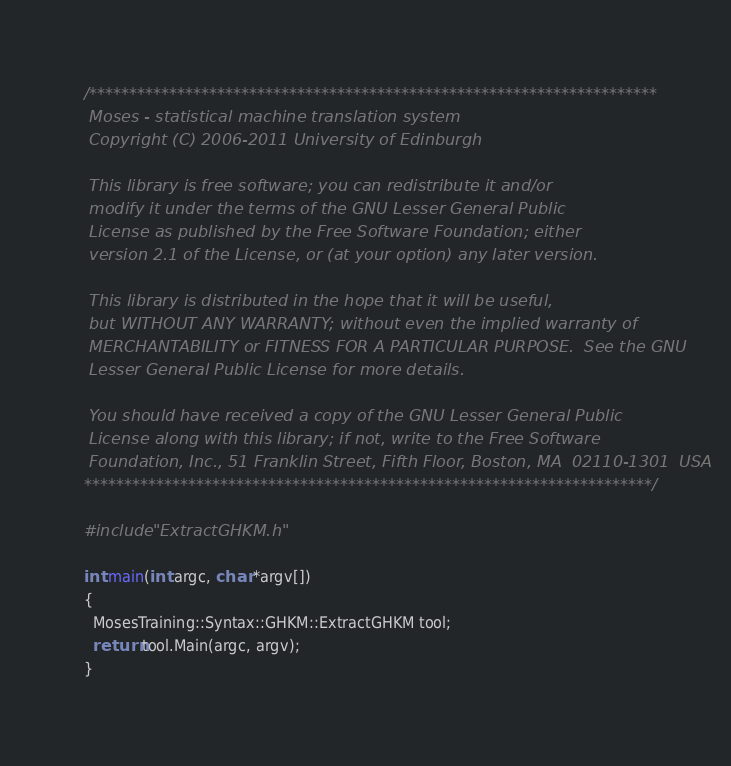Convert code to text. <code><loc_0><loc_0><loc_500><loc_500><_C++_>/***********************************************************************
 Moses - statistical machine translation system
 Copyright (C) 2006-2011 University of Edinburgh

 This library is free software; you can redistribute it and/or
 modify it under the terms of the GNU Lesser General Public
 License as published by the Free Software Foundation; either
 version 2.1 of the License, or (at your option) any later version.

 This library is distributed in the hope that it will be useful,
 but WITHOUT ANY WARRANTY; without even the implied warranty of
 MERCHANTABILITY or FITNESS FOR A PARTICULAR PURPOSE.  See the GNU
 Lesser General Public License for more details.

 You should have received a copy of the GNU Lesser General Public
 License along with this library; if not, write to the Free Software
 Foundation, Inc., 51 Franklin Street, Fifth Floor, Boston, MA  02110-1301  USA
***********************************************************************/

#include "ExtractGHKM.h"

int main(int argc, char *argv[])
{
  MosesTraining::Syntax::GHKM::ExtractGHKM tool;
  return tool.Main(argc, argv);
}
</code> 